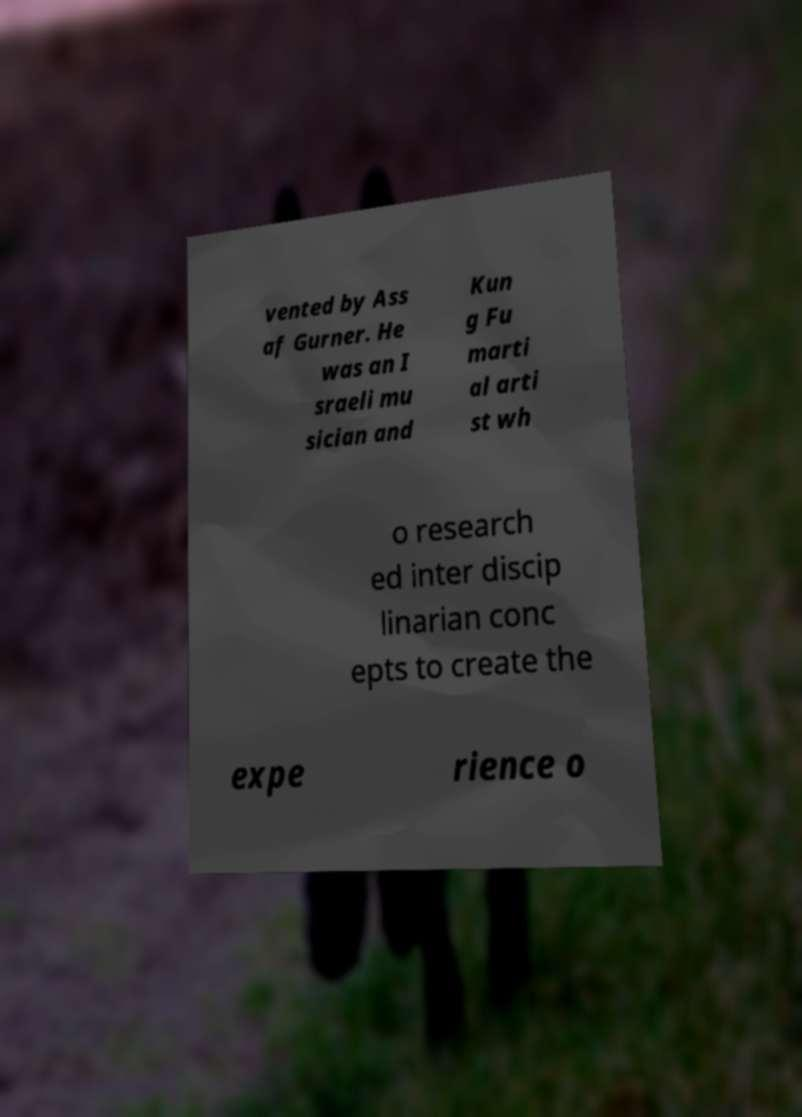Can you read and provide the text displayed in the image?This photo seems to have some interesting text. Can you extract and type it out for me? vented by Ass af Gurner. He was an I sraeli mu sician and Kun g Fu marti al arti st wh o research ed inter discip linarian conc epts to create the expe rience o 